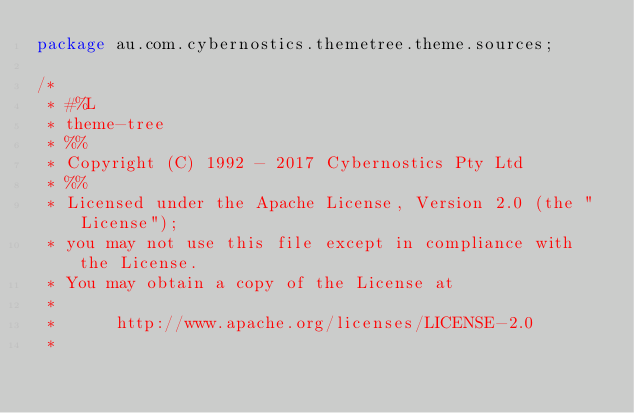Convert code to text. <code><loc_0><loc_0><loc_500><loc_500><_Java_>package au.com.cybernostics.themetree.theme.sources;

/*
 * #%L
 * theme-tree
 * %%
 * Copyright (C) 1992 - 2017 Cybernostics Pty Ltd
 * %%
 * Licensed under the Apache License, Version 2.0 (the "License");
 * you may not use this file except in compliance with the License.
 * You may obtain a copy of the License at
 *
 *      http://www.apache.org/licenses/LICENSE-2.0
 *</code> 